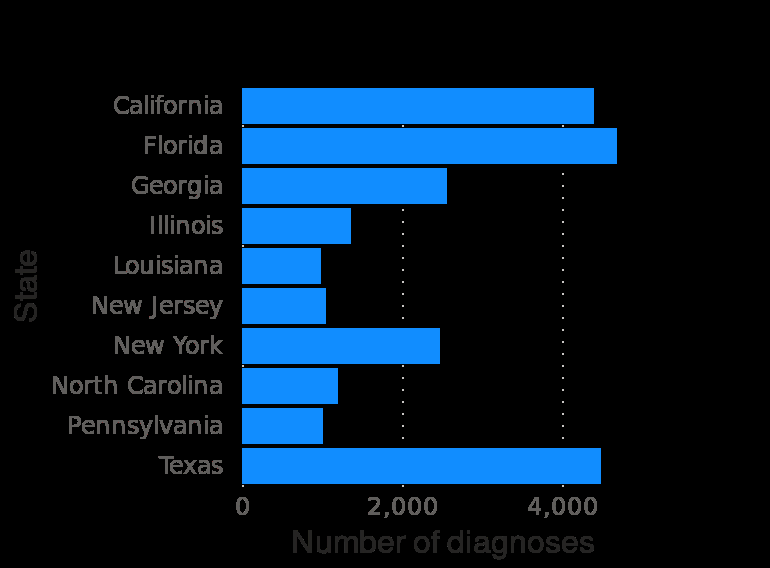<image>
Describe the following image in detail U.S. states with the highest number of HIV diagnoses in 2018 is a bar plot. The y-axis measures State while the x-axis shows Number of diagnoses. 